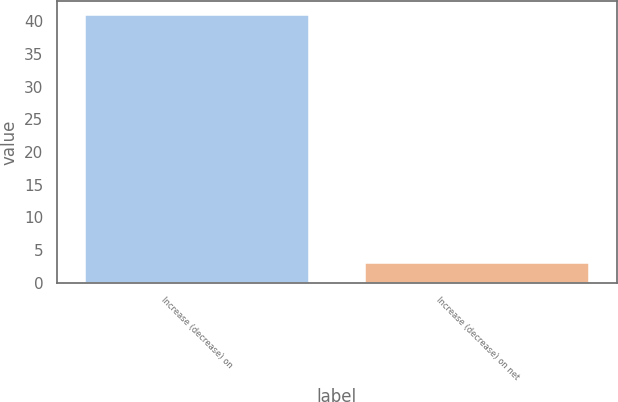<chart> <loc_0><loc_0><loc_500><loc_500><bar_chart><fcel>Increase (decrease) on<fcel>Increase (decrease) on net<nl><fcel>41<fcel>3<nl></chart> 